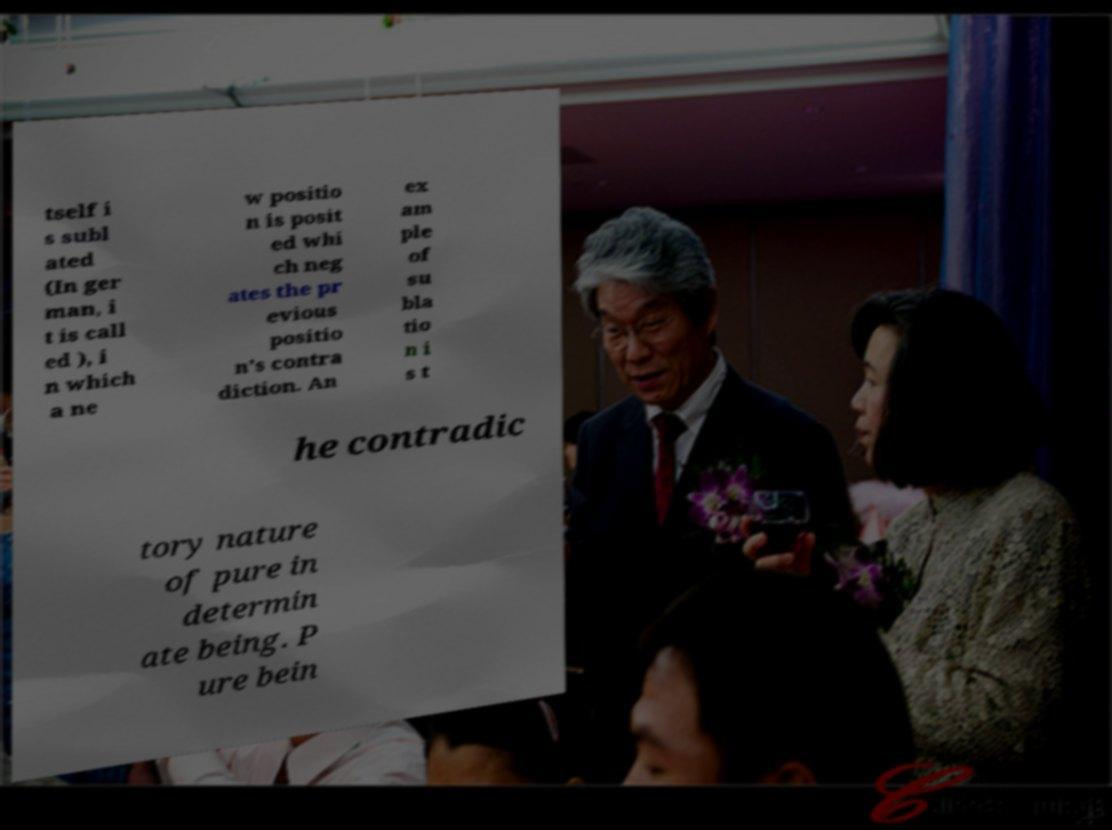For documentation purposes, I need the text within this image transcribed. Could you provide that? tself i s subl ated (In ger man, i t is call ed ), i n which a ne w positio n is posit ed whi ch neg ates the pr evious positio n's contra diction. An ex am ple of su bla tio n i s t he contradic tory nature of pure in determin ate being. P ure bein 